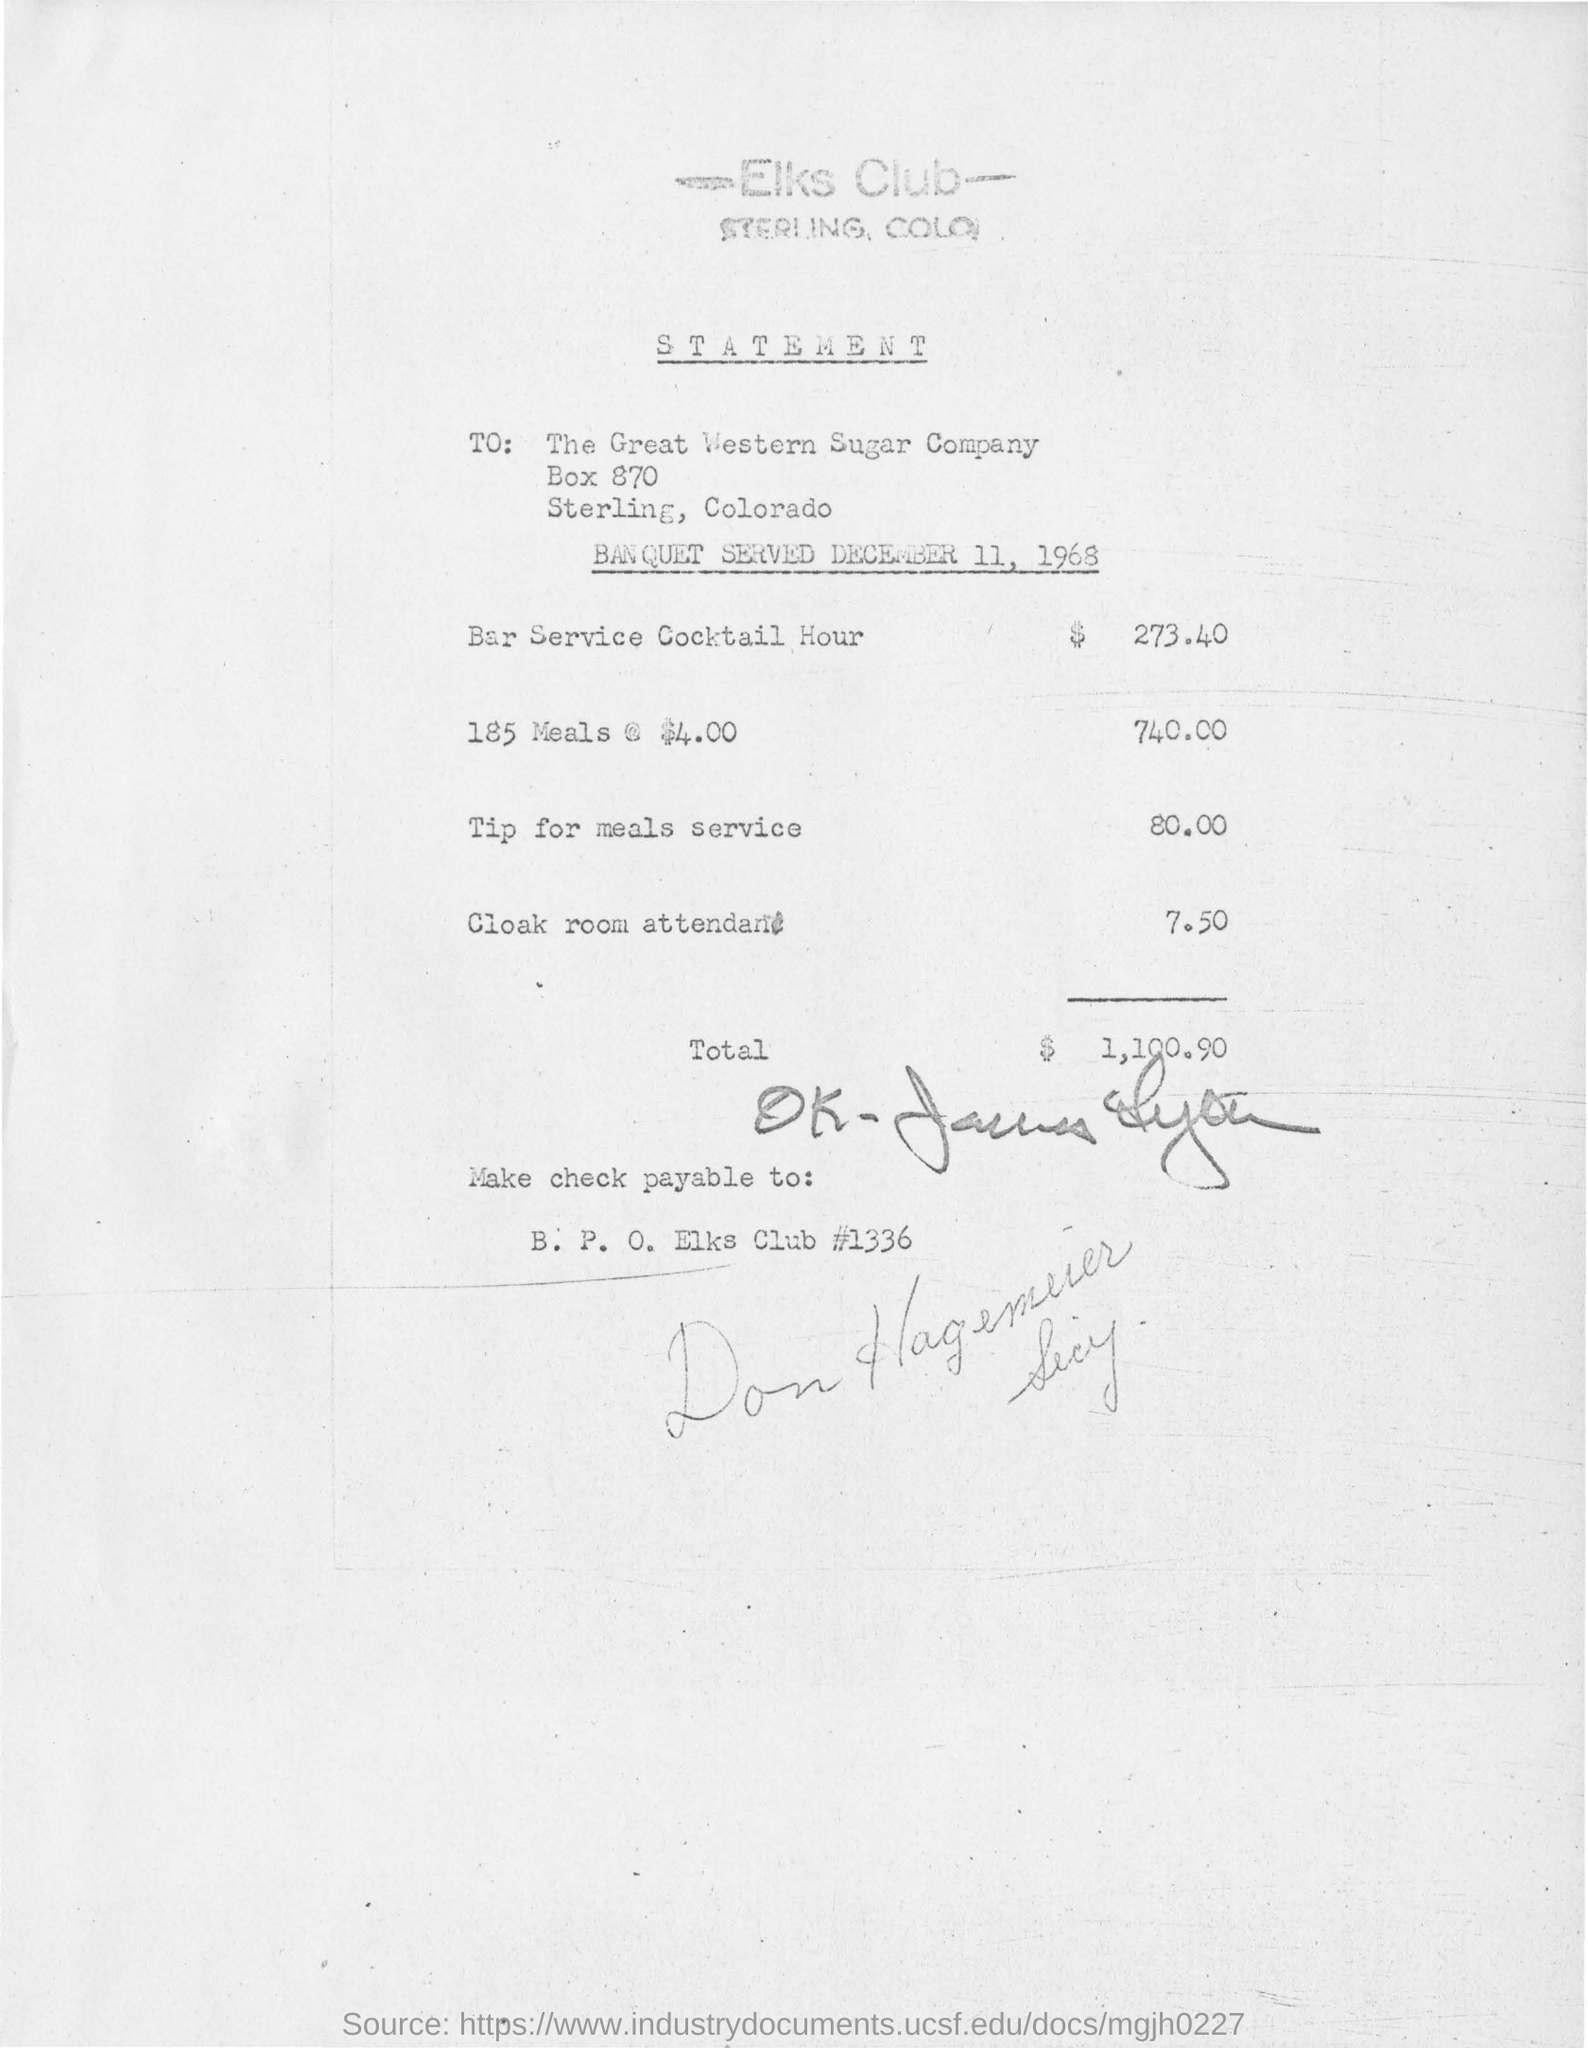To whom the statement is addressed to ?
Give a very brief answer. The Great Western Sugar Company. What is the statement in regard of ?
Provide a short and direct response. BANQUET SERVED DECEMBER 11,  1968. What is the amount for cloak room attendant?
Keep it short and to the point. 7.50. What is the total amount in the statement?
Your answer should be very brief. 1,100.90. 